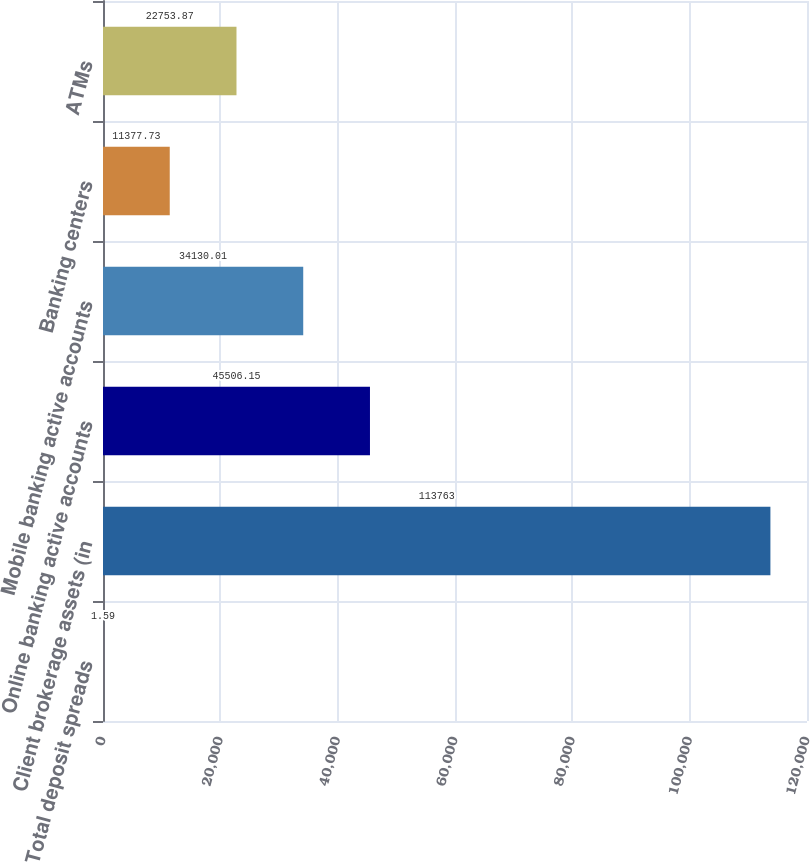Convert chart to OTSL. <chart><loc_0><loc_0><loc_500><loc_500><bar_chart><fcel>Total deposit spreads<fcel>Client brokerage assets (in<fcel>Online banking active accounts<fcel>Mobile banking active accounts<fcel>Banking centers<fcel>ATMs<nl><fcel>1.59<fcel>113763<fcel>45506.2<fcel>34130<fcel>11377.7<fcel>22753.9<nl></chart> 